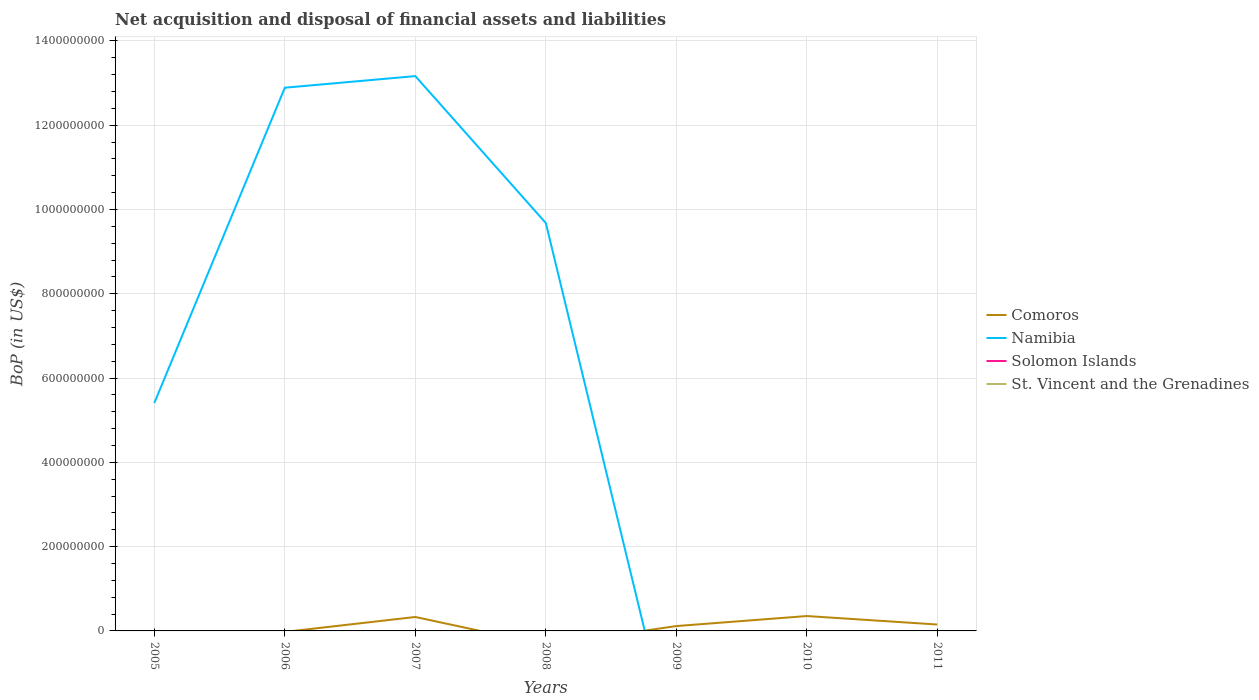Does the line corresponding to St. Vincent and the Grenadines intersect with the line corresponding to Solomon Islands?
Keep it short and to the point. Yes. Is the number of lines equal to the number of legend labels?
Your answer should be compact. No. Across all years, what is the maximum Balance of Payments in Solomon Islands?
Offer a very short reply. 0. What is the difference between the highest and the second highest Balance of Payments in Comoros?
Provide a short and direct response. 3.53e+07. How many years are there in the graph?
Offer a terse response. 7. What is the difference between two consecutive major ticks on the Y-axis?
Provide a succinct answer. 2.00e+08. Are the values on the major ticks of Y-axis written in scientific E-notation?
Your response must be concise. No. Does the graph contain any zero values?
Your answer should be very brief. Yes. Does the graph contain grids?
Your answer should be very brief. Yes. Where does the legend appear in the graph?
Your answer should be compact. Center right. What is the title of the graph?
Offer a terse response. Net acquisition and disposal of financial assets and liabilities. What is the label or title of the Y-axis?
Your answer should be compact. BoP (in US$). What is the BoP (in US$) of Comoros in 2005?
Ensure brevity in your answer.  0. What is the BoP (in US$) in Namibia in 2005?
Keep it short and to the point. 5.41e+08. What is the BoP (in US$) of St. Vincent and the Grenadines in 2005?
Your response must be concise. 0. What is the BoP (in US$) in Namibia in 2006?
Offer a very short reply. 1.29e+09. What is the BoP (in US$) of St. Vincent and the Grenadines in 2006?
Make the answer very short. 0. What is the BoP (in US$) in Comoros in 2007?
Provide a succinct answer. 3.31e+07. What is the BoP (in US$) in Namibia in 2007?
Provide a succinct answer. 1.32e+09. What is the BoP (in US$) of Solomon Islands in 2007?
Provide a succinct answer. 0. What is the BoP (in US$) in St. Vincent and the Grenadines in 2007?
Provide a short and direct response. 0. What is the BoP (in US$) of Namibia in 2008?
Provide a short and direct response. 9.68e+08. What is the BoP (in US$) of St. Vincent and the Grenadines in 2008?
Give a very brief answer. 0. What is the BoP (in US$) in Comoros in 2009?
Offer a very short reply. 1.15e+07. What is the BoP (in US$) of Namibia in 2009?
Keep it short and to the point. 0. What is the BoP (in US$) of Solomon Islands in 2009?
Your response must be concise. 0. What is the BoP (in US$) in Comoros in 2010?
Provide a succinct answer. 3.53e+07. What is the BoP (in US$) of Comoros in 2011?
Your answer should be compact. 1.52e+07. What is the BoP (in US$) in Solomon Islands in 2011?
Keep it short and to the point. 0. Across all years, what is the maximum BoP (in US$) in Comoros?
Offer a terse response. 3.53e+07. Across all years, what is the maximum BoP (in US$) of Namibia?
Keep it short and to the point. 1.32e+09. Across all years, what is the minimum BoP (in US$) in Comoros?
Your response must be concise. 0. What is the total BoP (in US$) of Comoros in the graph?
Offer a very short reply. 9.51e+07. What is the total BoP (in US$) in Namibia in the graph?
Keep it short and to the point. 4.11e+09. What is the total BoP (in US$) of Solomon Islands in the graph?
Ensure brevity in your answer.  0. What is the total BoP (in US$) of St. Vincent and the Grenadines in the graph?
Your answer should be compact. 0. What is the difference between the BoP (in US$) of Namibia in 2005 and that in 2006?
Make the answer very short. -7.48e+08. What is the difference between the BoP (in US$) of Namibia in 2005 and that in 2007?
Offer a very short reply. -7.76e+08. What is the difference between the BoP (in US$) in Namibia in 2005 and that in 2008?
Your response must be concise. -4.27e+08. What is the difference between the BoP (in US$) of Namibia in 2006 and that in 2007?
Provide a short and direct response. -2.76e+07. What is the difference between the BoP (in US$) of Namibia in 2006 and that in 2008?
Ensure brevity in your answer.  3.21e+08. What is the difference between the BoP (in US$) of Namibia in 2007 and that in 2008?
Give a very brief answer. 3.49e+08. What is the difference between the BoP (in US$) of Comoros in 2007 and that in 2009?
Your response must be concise. 2.16e+07. What is the difference between the BoP (in US$) of Comoros in 2007 and that in 2010?
Give a very brief answer. -2.22e+06. What is the difference between the BoP (in US$) in Comoros in 2007 and that in 2011?
Your answer should be very brief. 1.79e+07. What is the difference between the BoP (in US$) of Comoros in 2009 and that in 2010?
Provide a succinct answer. -2.38e+07. What is the difference between the BoP (in US$) of Comoros in 2009 and that in 2011?
Make the answer very short. -3.65e+06. What is the difference between the BoP (in US$) of Comoros in 2010 and that in 2011?
Give a very brief answer. 2.01e+07. What is the difference between the BoP (in US$) in Comoros in 2007 and the BoP (in US$) in Namibia in 2008?
Make the answer very short. -9.35e+08. What is the average BoP (in US$) of Comoros per year?
Your response must be concise. 1.36e+07. What is the average BoP (in US$) in Namibia per year?
Keep it short and to the point. 5.88e+08. What is the average BoP (in US$) of Solomon Islands per year?
Offer a terse response. 0. In the year 2007, what is the difference between the BoP (in US$) in Comoros and BoP (in US$) in Namibia?
Offer a terse response. -1.28e+09. What is the ratio of the BoP (in US$) of Namibia in 2005 to that in 2006?
Ensure brevity in your answer.  0.42. What is the ratio of the BoP (in US$) of Namibia in 2005 to that in 2007?
Keep it short and to the point. 0.41. What is the ratio of the BoP (in US$) in Namibia in 2005 to that in 2008?
Provide a succinct answer. 0.56. What is the ratio of the BoP (in US$) in Namibia in 2006 to that in 2007?
Offer a very short reply. 0.98. What is the ratio of the BoP (in US$) in Namibia in 2006 to that in 2008?
Keep it short and to the point. 1.33. What is the ratio of the BoP (in US$) of Namibia in 2007 to that in 2008?
Offer a very short reply. 1.36. What is the ratio of the BoP (in US$) in Comoros in 2007 to that in 2009?
Provide a short and direct response. 2.87. What is the ratio of the BoP (in US$) of Comoros in 2007 to that in 2010?
Make the answer very short. 0.94. What is the ratio of the BoP (in US$) in Comoros in 2007 to that in 2011?
Offer a very short reply. 2.18. What is the ratio of the BoP (in US$) of Comoros in 2009 to that in 2010?
Provide a short and direct response. 0.33. What is the ratio of the BoP (in US$) in Comoros in 2009 to that in 2011?
Provide a short and direct response. 0.76. What is the ratio of the BoP (in US$) of Comoros in 2010 to that in 2011?
Offer a very short reply. 2.33. What is the difference between the highest and the second highest BoP (in US$) in Comoros?
Your answer should be compact. 2.22e+06. What is the difference between the highest and the second highest BoP (in US$) of Namibia?
Make the answer very short. 2.76e+07. What is the difference between the highest and the lowest BoP (in US$) of Comoros?
Provide a succinct answer. 3.53e+07. What is the difference between the highest and the lowest BoP (in US$) in Namibia?
Keep it short and to the point. 1.32e+09. 